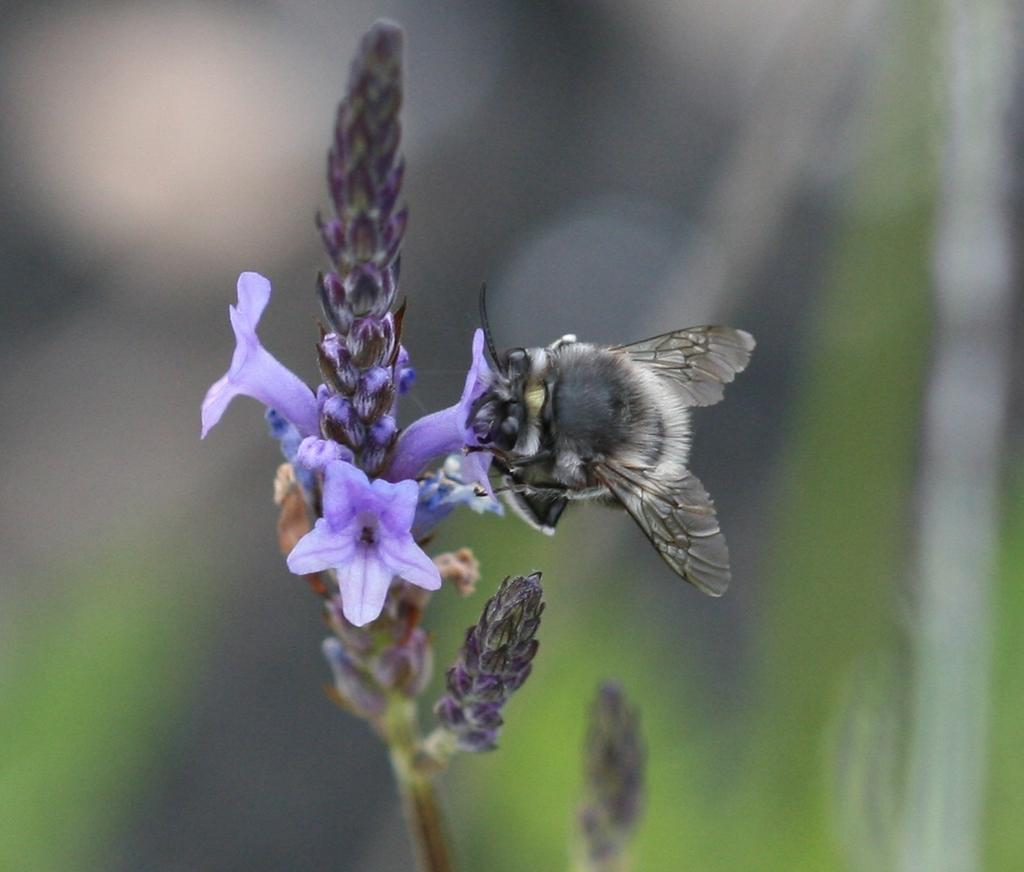What type of insect is present in the image? There is a honey bee in the image. Where is the honey bee located in the image? The honey bee is on the flower region of a plant. What color is the arch in the image? There is no arch present in the image; it features a honey bee on a plant. 